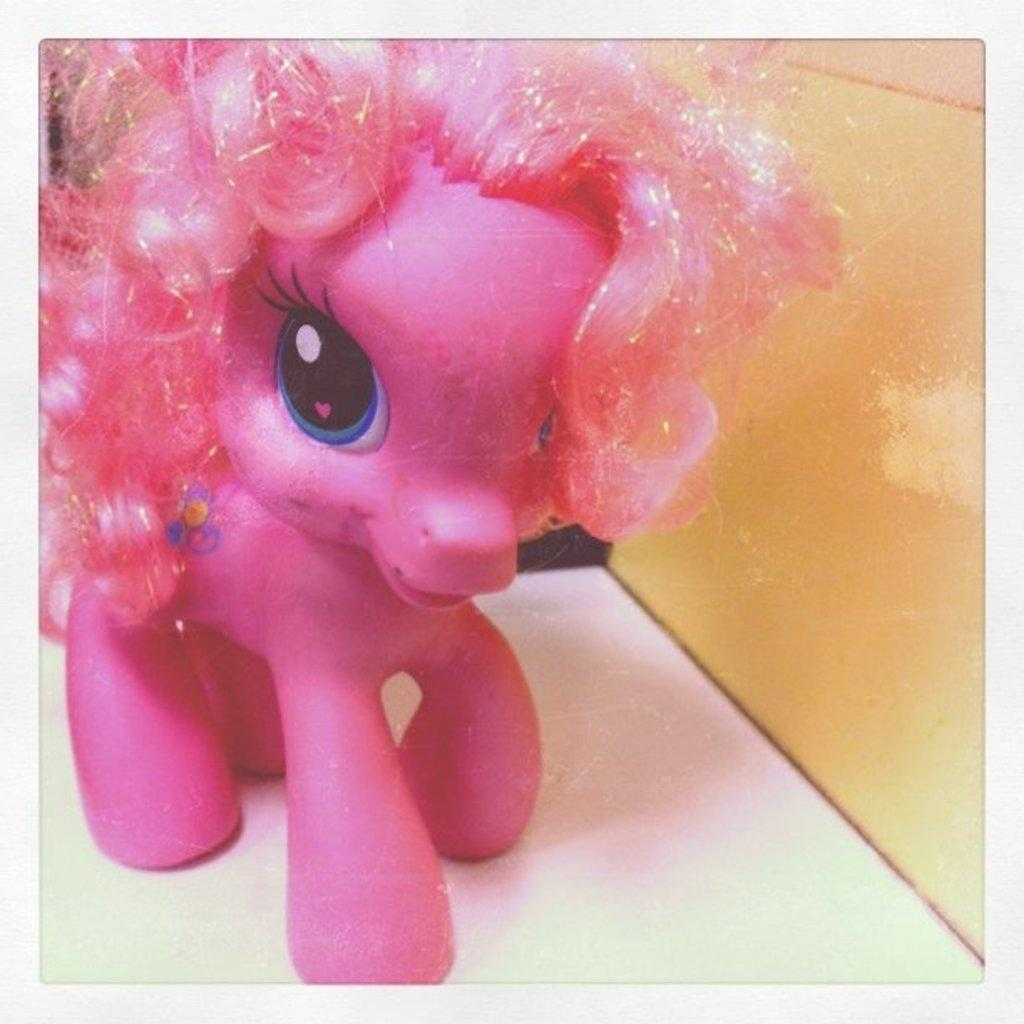What is the color of the toy in the image? The toy in the image is pink. What specific feature does the pink toy have? The pink toy has pink hair. Where is the pink toy located in the image? The pink toy is on a table. Can you see the pink toy taking a flight in the image? No, the pink toy is not taking a flight in the image; it is on a table. Is the pink toy swimming in the ocean in the image? No, the pink toy is not swimming in the ocean in the image; it is on a table. 